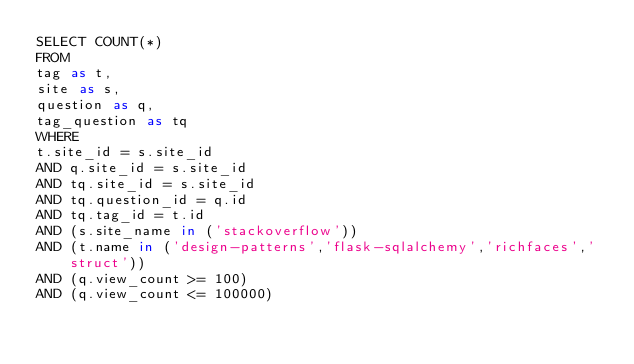<code> <loc_0><loc_0><loc_500><loc_500><_SQL_>SELECT COUNT(*)
FROM
tag as t,
site as s,
question as q,
tag_question as tq
WHERE
t.site_id = s.site_id
AND q.site_id = s.site_id
AND tq.site_id = s.site_id
AND tq.question_id = q.id
AND tq.tag_id = t.id
AND (s.site_name in ('stackoverflow'))
AND (t.name in ('design-patterns','flask-sqlalchemy','richfaces','struct'))
AND (q.view_count >= 100)
AND (q.view_count <= 100000)
</code> 